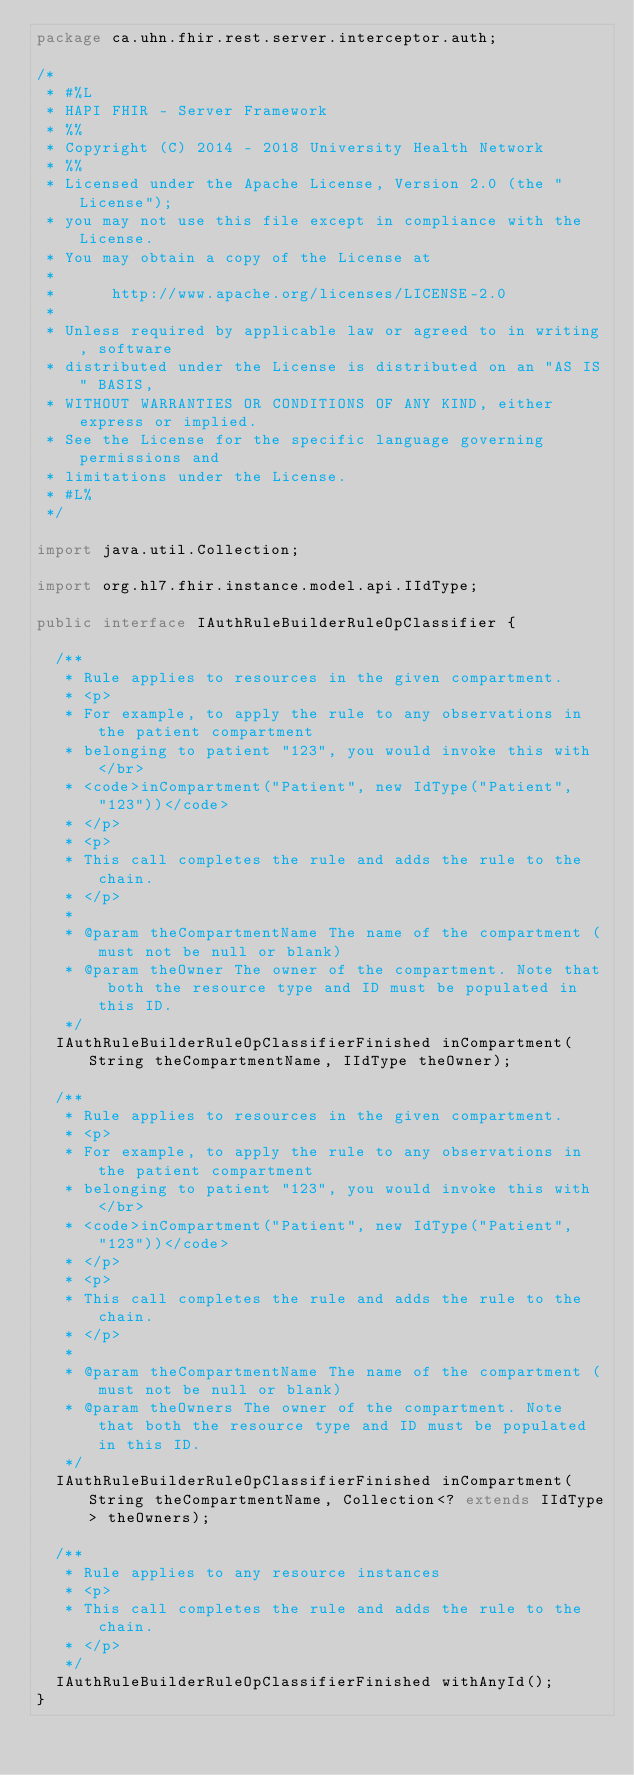Convert code to text. <code><loc_0><loc_0><loc_500><loc_500><_Java_>package ca.uhn.fhir.rest.server.interceptor.auth;

/*
 * #%L
 * HAPI FHIR - Server Framework
 * %%
 * Copyright (C) 2014 - 2018 University Health Network
 * %%
 * Licensed under the Apache License, Version 2.0 (the "License");
 * you may not use this file except in compliance with the License.
 * You may obtain a copy of the License at
 * 
 *      http://www.apache.org/licenses/LICENSE-2.0
 * 
 * Unless required by applicable law or agreed to in writing, software
 * distributed under the License is distributed on an "AS IS" BASIS,
 * WITHOUT WARRANTIES OR CONDITIONS OF ANY KIND, either express or implied.
 * See the License for the specific language governing permissions and
 * limitations under the License.
 * #L%
 */

import java.util.Collection;

import org.hl7.fhir.instance.model.api.IIdType;

public interface IAuthRuleBuilderRuleOpClassifier {

	/**
	 * Rule applies to resources in the given compartment.
	 * <p>
	 * For example, to apply the rule to any observations in the patient compartment
	 * belonging to patient "123", you would invoke this with</br>
	 * <code>inCompartment("Patient", new IdType("Patient", "123"))</code>
	 * </p>
	 * <p>
	 * This call completes the rule and adds the rule to the chain. 
	 * </p>
	 * 
	 * @param theCompartmentName The name of the compartment (must not be null or blank)
	 * @param theOwner The owner of the compartment. Note that both the resource type and ID must be populated in this ID.
	 */
	IAuthRuleBuilderRuleOpClassifierFinished inCompartment(String theCompartmentName, IIdType theOwner);

	/**
	 * Rule applies to resources in the given compartment.
	 * <p>
	 * For example, to apply the rule to any observations in the patient compartment
	 * belonging to patient "123", you would invoke this with</br>
	 * <code>inCompartment("Patient", new IdType("Patient", "123"))</code>
	 * </p>
	 * <p>
	 * This call completes the rule and adds the rule to the chain. 
	 * </p>
	 * 
	 * @param theCompartmentName The name of the compartment (must not be null or blank)
	 * @param theOwners The owner of the compartment. Note that both the resource type and ID must be populated in this ID.
	 */
	IAuthRuleBuilderRuleOpClassifierFinished inCompartment(String theCompartmentName, Collection<? extends IIdType> theOwners);

	/**
	 * Rule applies to any resource instances
	 * <p>
	 * This call completes the rule and adds the rule to the chain. 
	 * </p>
	 */
	IAuthRuleBuilderRuleOpClassifierFinished withAnyId();
}
</code> 